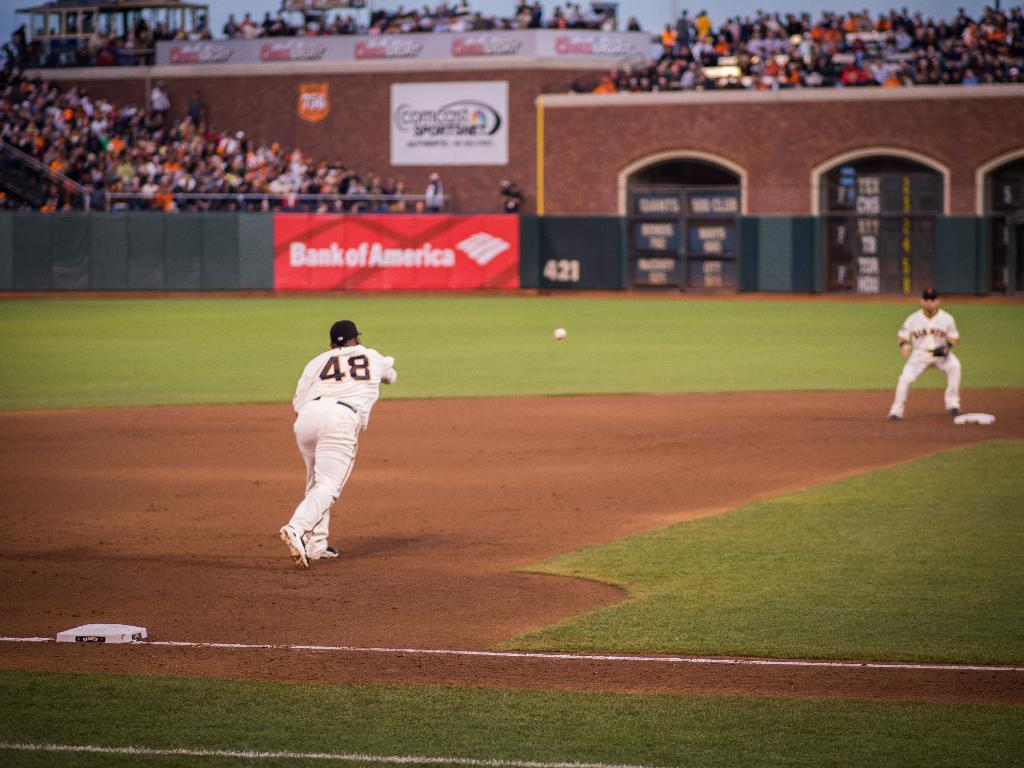<image>
Share a concise interpretation of the image provided. A Bank of America banner is in a baseball field. 